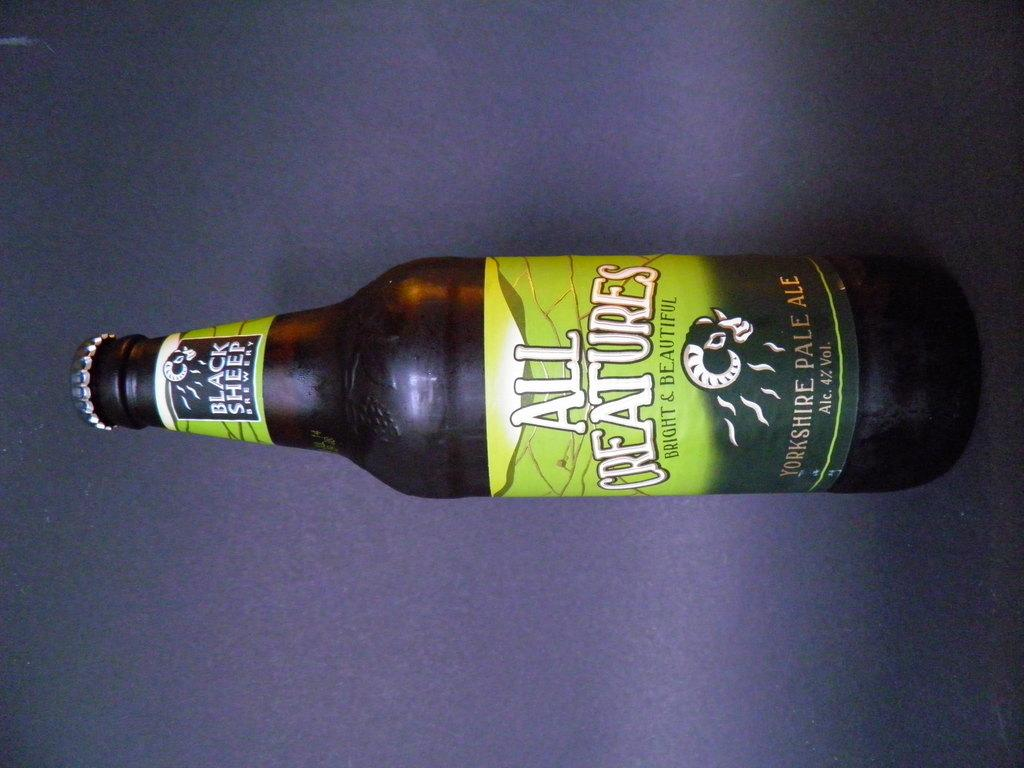<image>
Offer a succinct explanation of the picture presented. Beer bottle with a green label that says All Creatures. 